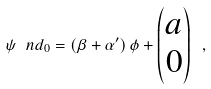Convert formula to latex. <formula><loc_0><loc_0><loc_500><loc_500>\psi \ n d _ { 0 } = ( \beta + \alpha ^ { \prime } ) \, \phi + \begin{pmatrix} a \\ 0 \end{pmatrix} \ ,</formula> 